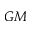<formula> <loc_0><loc_0><loc_500><loc_500>G M</formula> 